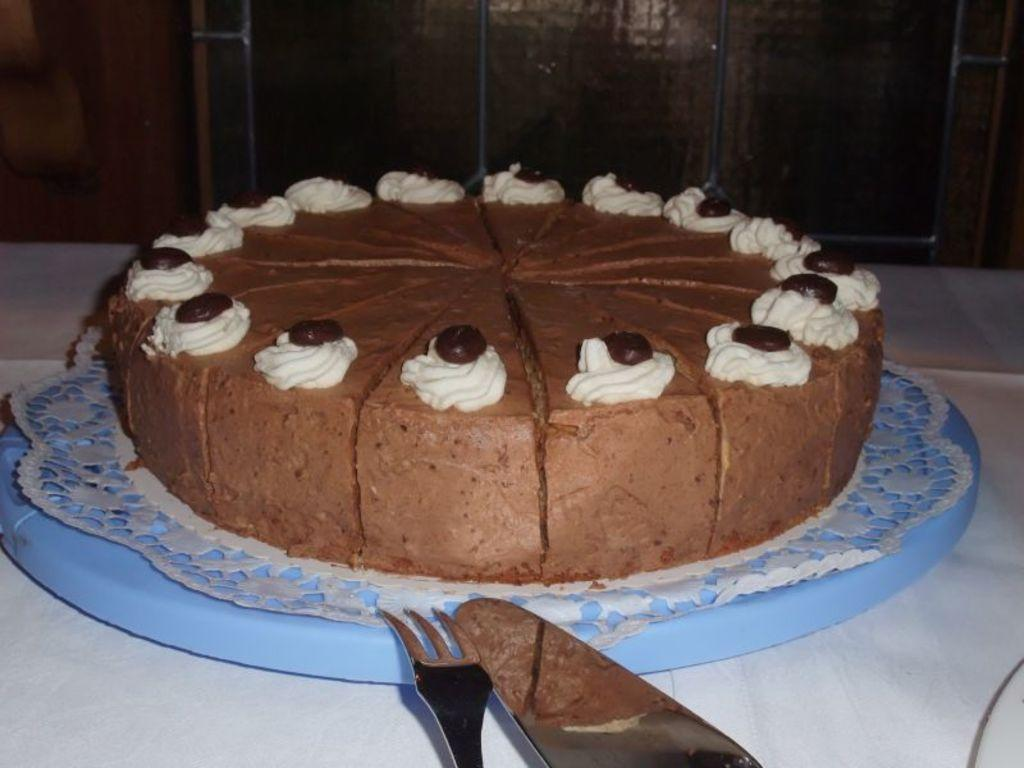What is the main food item visible in the image? There is a cake on a plate in the image. What utensils are present on the table in the image? There is a knife and a fork on the table in the image. What type of ink can be seen dripping from the cake in the image? There is no ink present in the image, and the cake is not dripping anything. 